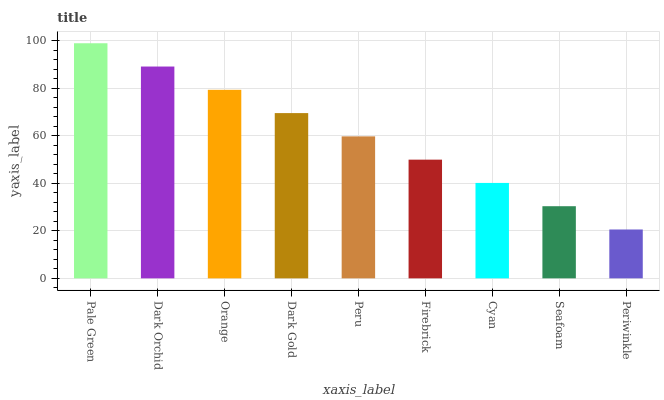Is Periwinkle the minimum?
Answer yes or no. Yes. Is Pale Green the maximum?
Answer yes or no. Yes. Is Dark Orchid the minimum?
Answer yes or no. No. Is Dark Orchid the maximum?
Answer yes or no. No. Is Pale Green greater than Dark Orchid?
Answer yes or no. Yes. Is Dark Orchid less than Pale Green?
Answer yes or no. Yes. Is Dark Orchid greater than Pale Green?
Answer yes or no. No. Is Pale Green less than Dark Orchid?
Answer yes or no. No. Is Peru the high median?
Answer yes or no. Yes. Is Peru the low median?
Answer yes or no. Yes. Is Firebrick the high median?
Answer yes or no. No. Is Dark Gold the low median?
Answer yes or no. No. 